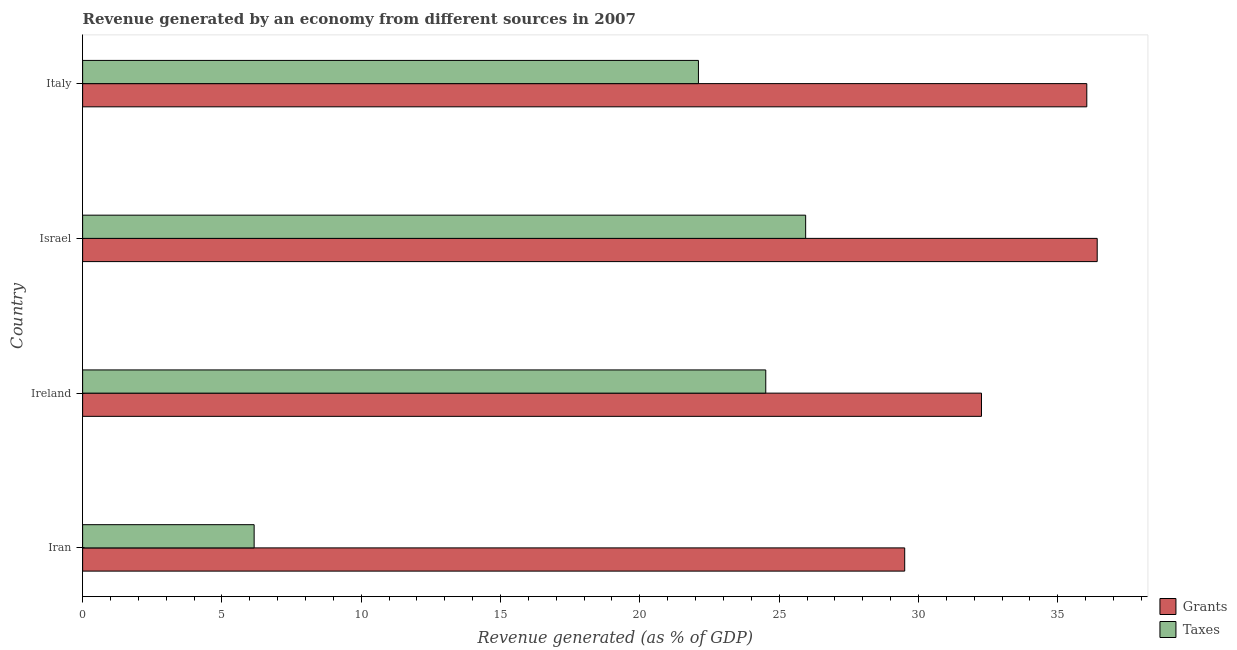Are the number of bars per tick equal to the number of legend labels?
Your answer should be compact. Yes. How many bars are there on the 2nd tick from the top?
Your answer should be compact. 2. What is the label of the 3rd group of bars from the top?
Give a very brief answer. Ireland. In how many cases, is the number of bars for a given country not equal to the number of legend labels?
Your answer should be compact. 0. What is the revenue generated by taxes in Iran?
Offer a terse response. 6.16. Across all countries, what is the maximum revenue generated by grants?
Provide a short and direct response. 36.42. Across all countries, what is the minimum revenue generated by grants?
Offer a very short reply. 29.51. In which country was the revenue generated by taxes maximum?
Make the answer very short. Israel. In which country was the revenue generated by taxes minimum?
Make the answer very short. Iran. What is the total revenue generated by taxes in the graph?
Provide a short and direct response. 78.73. What is the difference between the revenue generated by taxes in Iran and that in Israel?
Ensure brevity in your answer.  -19.8. What is the difference between the revenue generated by grants in Iran and the revenue generated by taxes in Italy?
Ensure brevity in your answer.  7.4. What is the average revenue generated by taxes per country?
Keep it short and to the point. 19.68. What is the difference between the revenue generated by taxes and revenue generated by grants in Israel?
Your answer should be compact. -10.46. In how many countries, is the revenue generated by taxes greater than 37 %?
Ensure brevity in your answer.  0. What is the ratio of the revenue generated by grants in Ireland to that in Italy?
Provide a short and direct response. 0.9. What is the difference between the highest and the second highest revenue generated by taxes?
Provide a short and direct response. 1.43. What is the difference between the highest and the lowest revenue generated by grants?
Make the answer very short. 6.91. In how many countries, is the revenue generated by taxes greater than the average revenue generated by taxes taken over all countries?
Offer a terse response. 3. Is the sum of the revenue generated by grants in Ireland and Israel greater than the maximum revenue generated by taxes across all countries?
Provide a succinct answer. Yes. What does the 2nd bar from the top in Iran represents?
Your answer should be compact. Grants. What does the 1st bar from the bottom in Israel represents?
Your answer should be very brief. Grants. Are all the bars in the graph horizontal?
Offer a very short reply. Yes. How many countries are there in the graph?
Offer a terse response. 4. Are the values on the major ticks of X-axis written in scientific E-notation?
Your answer should be compact. No. Does the graph contain any zero values?
Make the answer very short. No. How are the legend labels stacked?
Provide a short and direct response. Vertical. What is the title of the graph?
Ensure brevity in your answer.  Revenue generated by an economy from different sources in 2007. What is the label or title of the X-axis?
Keep it short and to the point. Revenue generated (as % of GDP). What is the Revenue generated (as % of GDP) in Grants in Iran?
Your answer should be very brief. 29.51. What is the Revenue generated (as % of GDP) of Taxes in Iran?
Provide a succinct answer. 6.16. What is the Revenue generated (as % of GDP) in Grants in Ireland?
Your response must be concise. 32.26. What is the Revenue generated (as % of GDP) of Taxes in Ireland?
Your answer should be compact. 24.52. What is the Revenue generated (as % of GDP) in Grants in Israel?
Provide a succinct answer. 36.42. What is the Revenue generated (as % of GDP) in Taxes in Israel?
Your answer should be very brief. 25.95. What is the Revenue generated (as % of GDP) of Grants in Italy?
Ensure brevity in your answer.  36.04. What is the Revenue generated (as % of GDP) of Taxes in Italy?
Ensure brevity in your answer.  22.1. Across all countries, what is the maximum Revenue generated (as % of GDP) of Grants?
Your answer should be very brief. 36.42. Across all countries, what is the maximum Revenue generated (as % of GDP) of Taxes?
Make the answer very short. 25.95. Across all countries, what is the minimum Revenue generated (as % of GDP) in Grants?
Provide a short and direct response. 29.51. Across all countries, what is the minimum Revenue generated (as % of GDP) in Taxes?
Make the answer very short. 6.16. What is the total Revenue generated (as % of GDP) of Grants in the graph?
Offer a terse response. 134.23. What is the total Revenue generated (as % of GDP) of Taxes in the graph?
Offer a very short reply. 78.73. What is the difference between the Revenue generated (as % of GDP) of Grants in Iran and that in Ireland?
Your response must be concise. -2.76. What is the difference between the Revenue generated (as % of GDP) in Taxes in Iran and that in Ireland?
Ensure brevity in your answer.  -18.36. What is the difference between the Revenue generated (as % of GDP) in Grants in Iran and that in Israel?
Ensure brevity in your answer.  -6.91. What is the difference between the Revenue generated (as % of GDP) in Taxes in Iran and that in Israel?
Make the answer very short. -19.8. What is the difference between the Revenue generated (as % of GDP) of Grants in Iran and that in Italy?
Provide a short and direct response. -6.54. What is the difference between the Revenue generated (as % of GDP) of Taxes in Iran and that in Italy?
Give a very brief answer. -15.95. What is the difference between the Revenue generated (as % of GDP) of Grants in Ireland and that in Israel?
Offer a terse response. -4.15. What is the difference between the Revenue generated (as % of GDP) in Taxes in Ireland and that in Israel?
Your answer should be compact. -1.43. What is the difference between the Revenue generated (as % of GDP) in Grants in Ireland and that in Italy?
Your response must be concise. -3.78. What is the difference between the Revenue generated (as % of GDP) of Taxes in Ireland and that in Italy?
Offer a very short reply. 2.42. What is the difference between the Revenue generated (as % of GDP) of Grants in Israel and that in Italy?
Offer a terse response. 0.37. What is the difference between the Revenue generated (as % of GDP) of Taxes in Israel and that in Italy?
Your answer should be compact. 3.85. What is the difference between the Revenue generated (as % of GDP) in Grants in Iran and the Revenue generated (as % of GDP) in Taxes in Ireland?
Offer a terse response. 4.99. What is the difference between the Revenue generated (as % of GDP) of Grants in Iran and the Revenue generated (as % of GDP) of Taxes in Israel?
Provide a succinct answer. 3.55. What is the difference between the Revenue generated (as % of GDP) in Grants in Iran and the Revenue generated (as % of GDP) in Taxes in Italy?
Provide a short and direct response. 7.4. What is the difference between the Revenue generated (as % of GDP) of Grants in Ireland and the Revenue generated (as % of GDP) of Taxes in Israel?
Keep it short and to the point. 6.31. What is the difference between the Revenue generated (as % of GDP) of Grants in Ireland and the Revenue generated (as % of GDP) of Taxes in Italy?
Offer a very short reply. 10.16. What is the difference between the Revenue generated (as % of GDP) of Grants in Israel and the Revenue generated (as % of GDP) of Taxes in Italy?
Offer a terse response. 14.31. What is the average Revenue generated (as % of GDP) in Grants per country?
Give a very brief answer. 33.56. What is the average Revenue generated (as % of GDP) in Taxes per country?
Ensure brevity in your answer.  19.68. What is the difference between the Revenue generated (as % of GDP) in Grants and Revenue generated (as % of GDP) in Taxes in Iran?
Your answer should be compact. 23.35. What is the difference between the Revenue generated (as % of GDP) of Grants and Revenue generated (as % of GDP) of Taxes in Ireland?
Give a very brief answer. 7.74. What is the difference between the Revenue generated (as % of GDP) in Grants and Revenue generated (as % of GDP) in Taxes in Israel?
Make the answer very short. 10.46. What is the difference between the Revenue generated (as % of GDP) of Grants and Revenue generated (as % of GDP) of Taxes in Italy?
Your answer should be compact. 13.94. What is the ratio of the Revenue generated (as % of GDP) in Grants in Iran to that in Ireland?
Offer a terse response. 0.91. What is the ratio of the Revenue generated (as % of GDP) in Taxes in Iran to that in Ireland?
Your response must be concise. 0.25. What is the ratio of the Revenue generated (as % of GDP) in Grants in Iran to that in Israel?
Offer a very short reply. 0.81. What is the ratio of the Revenue generated (as % of GDP) in Taxes in Iran to that in Israel?
Keep it short and to the point. 0.24. What is the ratio of the Revenue generated (as % of GDP) in Grants in Iran to that in Italy?
Provide a short and direct response. 0.82. What is the ratio of the Revenue generated (as % of GDP) of Taxes in Iran to that in Italy?
Give a very brief answer. 0.28. What is the ratio of the Revenue generated (as % of GDP) of Grants in Ireland to that in Israel?
Offer a terse response. 0.89. What is the ratio of the Revenue generated (as % of GDP) in Taxes in Ireland to that in Israel?
Offer a very short reply. 0.94. What is the ratio of the Revenue generated (as % of GDP) of Grants in Ireland to that in Italy?
Offer a terse response. 0.9. What is the ratio of the Revenue generated (as % of GDP) of Taxes in Ireland to that in Italy?
Your response must be concise. 1.11. What is the ratio of the Revenue generated (as % of GDP) in Grants in Israel to that in Italy?
Make the answer very short. 1.01. What is the ratio of the Revenue generated (as % of GDP) in Taxes in Israel to that in Italy?
Provide a short and direct response. 1.17. What is the difference between the highest and the second highest Revenue generated (as % of GDP) of Grants?
Offer a very short reply. 0.37. What is the difference between the highest and the second highest Revenue generated (as % of GDP) in Taxes?
Your answer should be compact. 1.43. What is the difference between the highest and the lowest Revenue generated (as % of GDP) of Grants?
Your answer should be compact. 6.91. What is the difference between the highest and the lowest Revenue generated (as % of GDP) of Taxes?
Offer a very short reply. 19.8. 